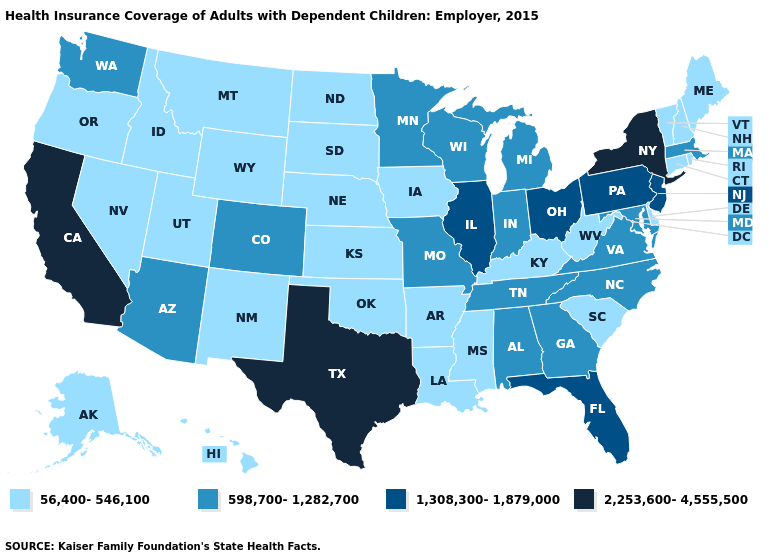What is the value of Kansas?
Keep it brief. 56,400-546,100. Does South Dakota have the same value as Pennsylvania?
Be succinct. No. Name the states that have a value in the range 598,700-1,282,700?
Write a very short answer. Alabama, Arizona, Colorado, Georgia, Indiana, Maryland, Massachusetts, Michigan, Minnesota, Missouri, North Carolina, Tennessee, Virginia, Washington, Wisconsin. Name the states that have a value in the range 2,253,600-4,555,500?
Answer briefly. California, New York, Texas. What is the value of Missouri?
Be succinct. 598,700-1,282,700. What is the value of Arkansas?
Write a very short answer. 56,400-546,100. What is the value of Florida?
Short answer required. 1,308,300-1,879,000. Among the states that border Colorado , does Kansas have the highest value?
Short answer required. No. Does Texas have the highest value in the USA?
Keep it brief. Yes. Name the states that have a value in the range 1,308,300-1,879,000?
Short answer required. Florida, Illinois, New Jersey, Ohio, Pennsylvania. Among the states that border Colorado , which have the lowest value?
Give a very brief answer. Kansas, Nebraska, New Mexico, Oklahoma, Utah, Wyoming. What is the lowest value in states that border Rhode Island?
Quick response, please. 56,400-546,100. What is the value of Iowa?
Give a very brief answer. 56,400-546,100. Among the states that border Virginia , does Tennessee have the highest value?
Short answer required. Yes. Among the states that border Kansas , which have the highest value?
Write a very short answer. Colorado, Missouri. 